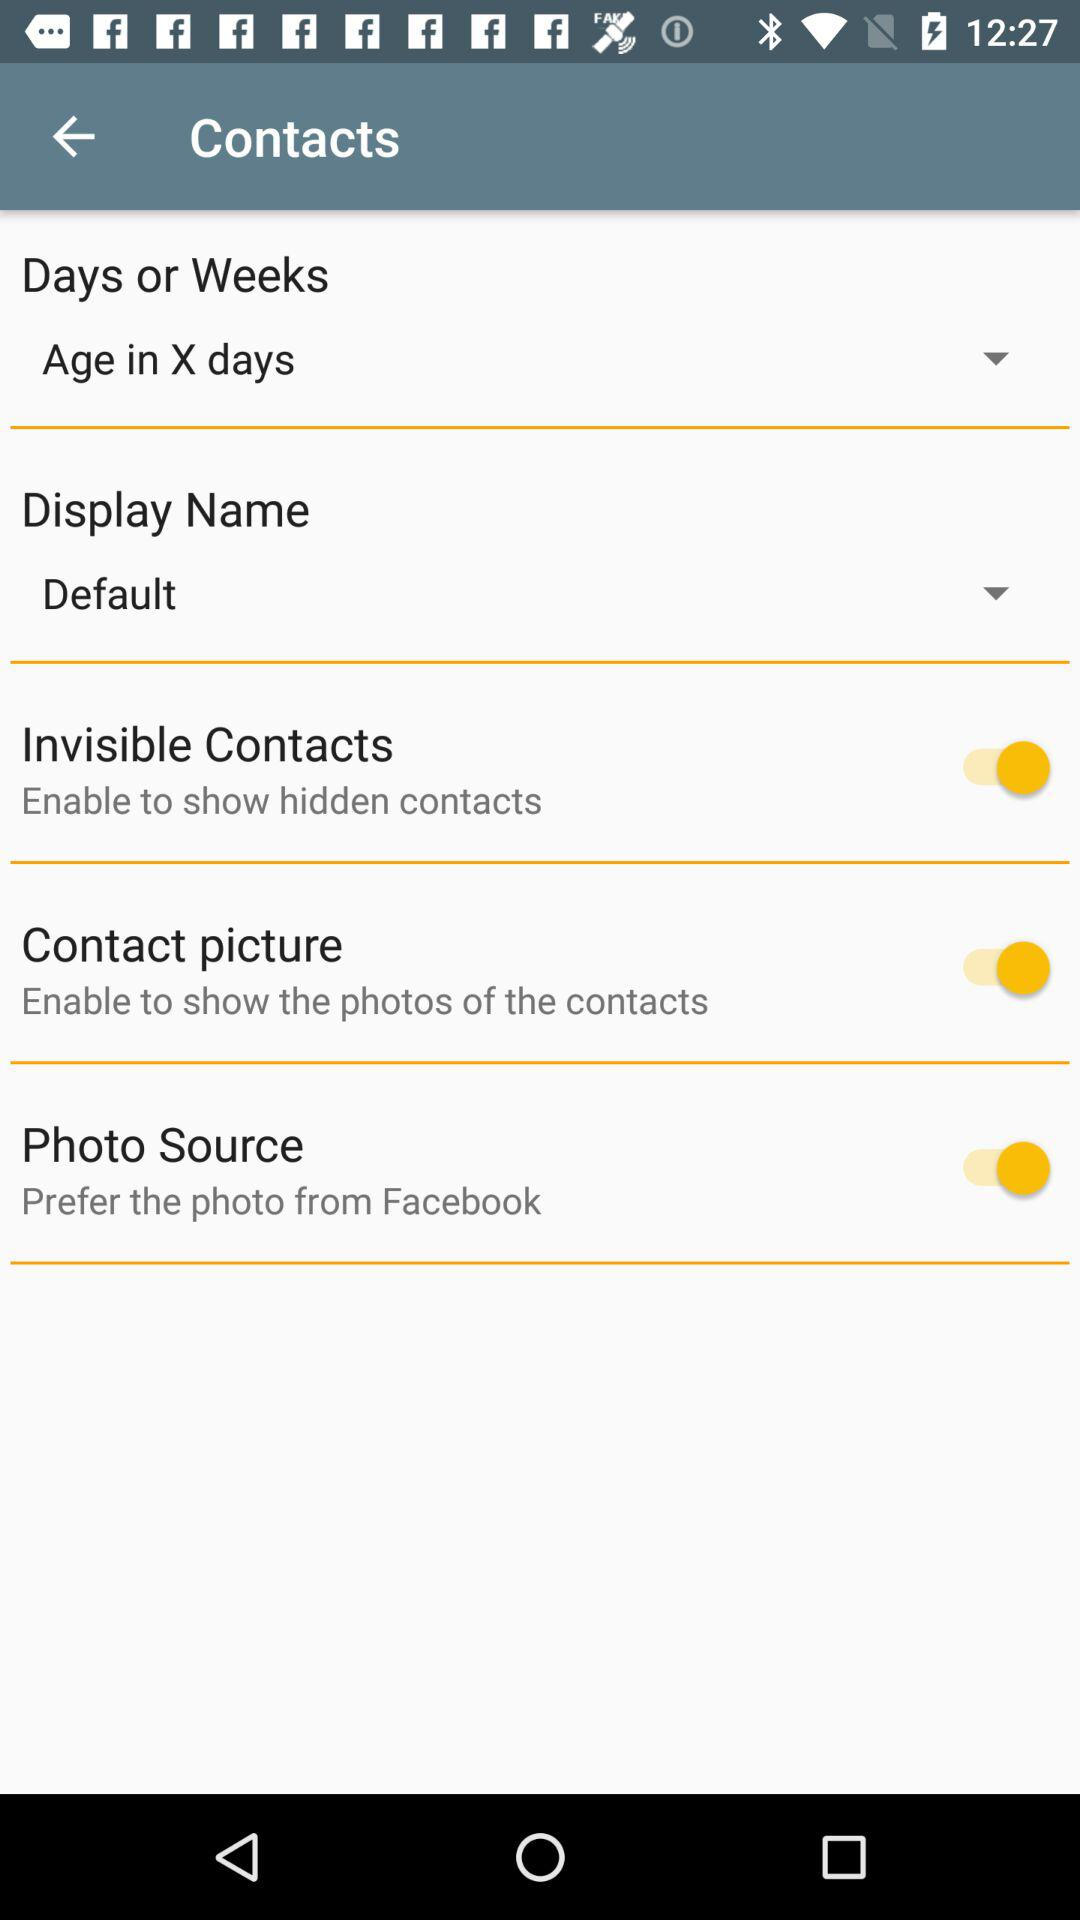What is the description of the "Contact picture" setting? The description is "Enable to show the photos of the contacts". 